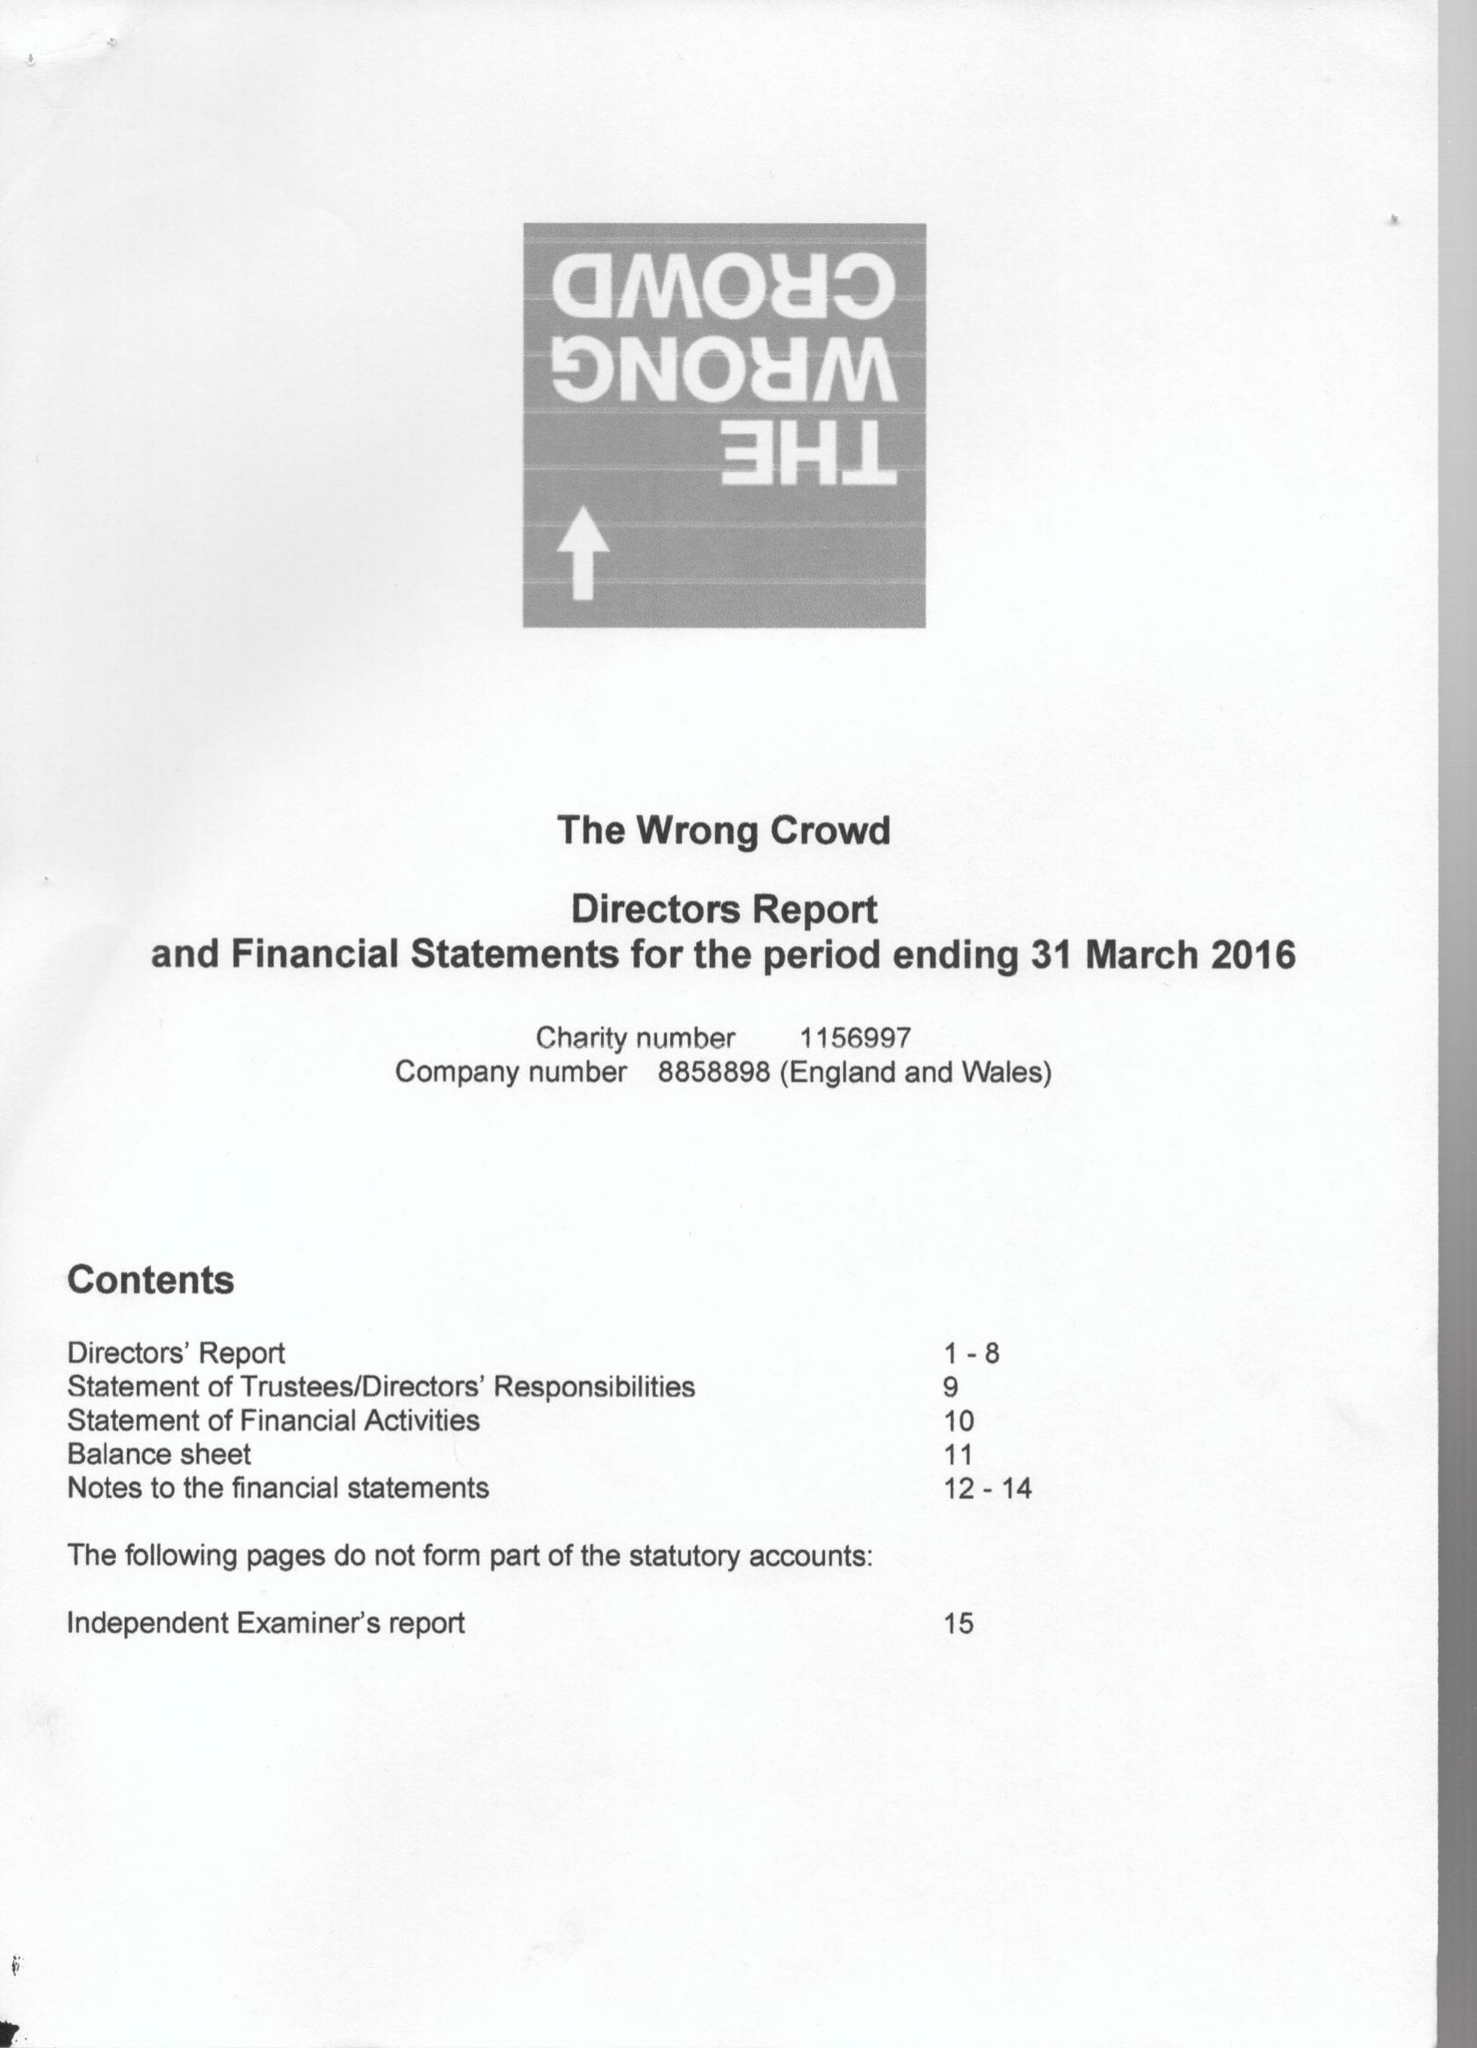What is the value for the address__post_town?
Answer the question using a single word or phrase. SOUTH BRENT 